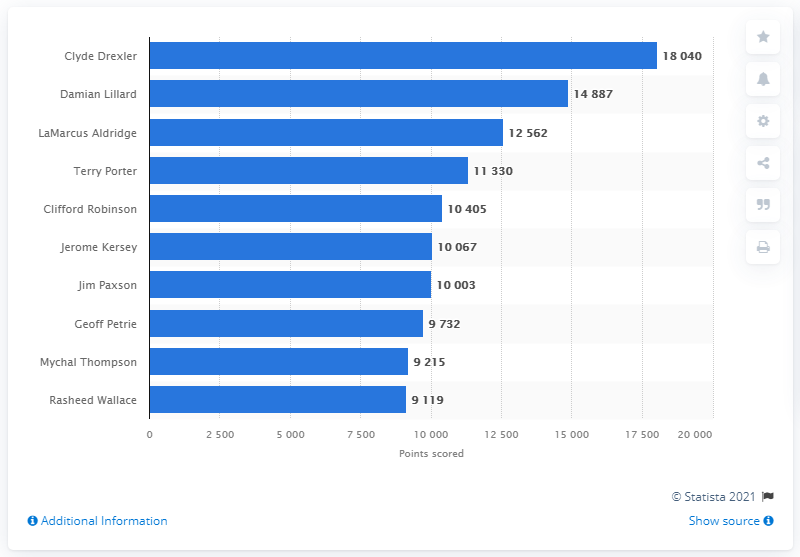Indicate a few pertinent items in this graphic. Clyde Drexler is the career points leader of the Portland Trail Blazers. 